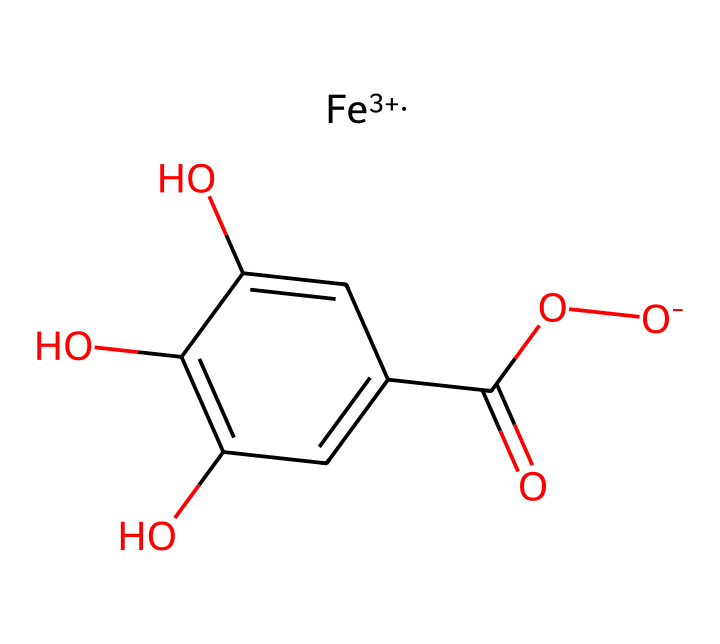What is the oxidation state of iron in this structure? The SMILES representation indicates the presence of [Fe+3], signifying that iron is in the +3 oxidation state.
Answer: +3 How many hydroxyl (–OH) groups are present? By analyzing the structure, we see that there are three -OH groups attached to the aromatic ring.
Answer: three What type of chemical compound is this? The presence of iron, along with carboxylate and hydroxyl groups, classifies this compound as an iron gall ink, which is an inorganic complex.
Answer: iron gall ink What is the total number of carbon atoms in this structure? Counting the carbon atoms in the molecule, there are six in the aromatic ring and one in the carboxylic acid group, resulting in a total of seven carbon atoms.
Answer: seven How many oxygen atoms are found in the structure? In the molecule, there are four oxygen atoms: three from the hydroxyl groups and one from the carboxylate group.
Answer: four What does the presence of iron indicate about the ink's properties? Iron contributes to the ink's ability to form complexes with tannins found in gall nuts, which affects the ink's permanence and color.
Answer: permanence Is this compound acidic or basic? Due to the presence of the carboxylic acid functional group (–COOH) and hydroxyl groups, the structure exhibits acidic properties.
Answer: acidic 